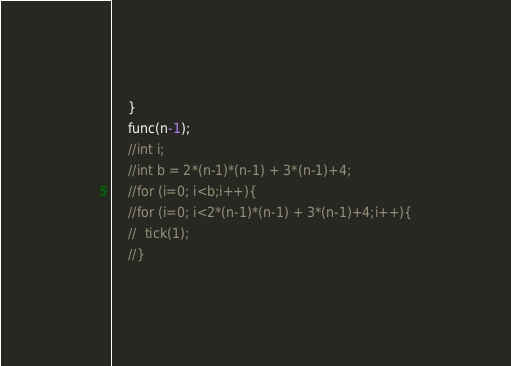Convert code to text. <code><loc_0><loc_0><loc_500><loc_500><_C_>    }
    func(n-1);
    //int i;
    //int b = 2*(n-1)*(n-1) + 3*(n-1)+4;
    //for (i=0; i<b;i++){
    //for (i=0; i<2*(n-1)*(n-1) + 3*(n-1)+4;i++){
    //  tick(1);
    //}</code> 